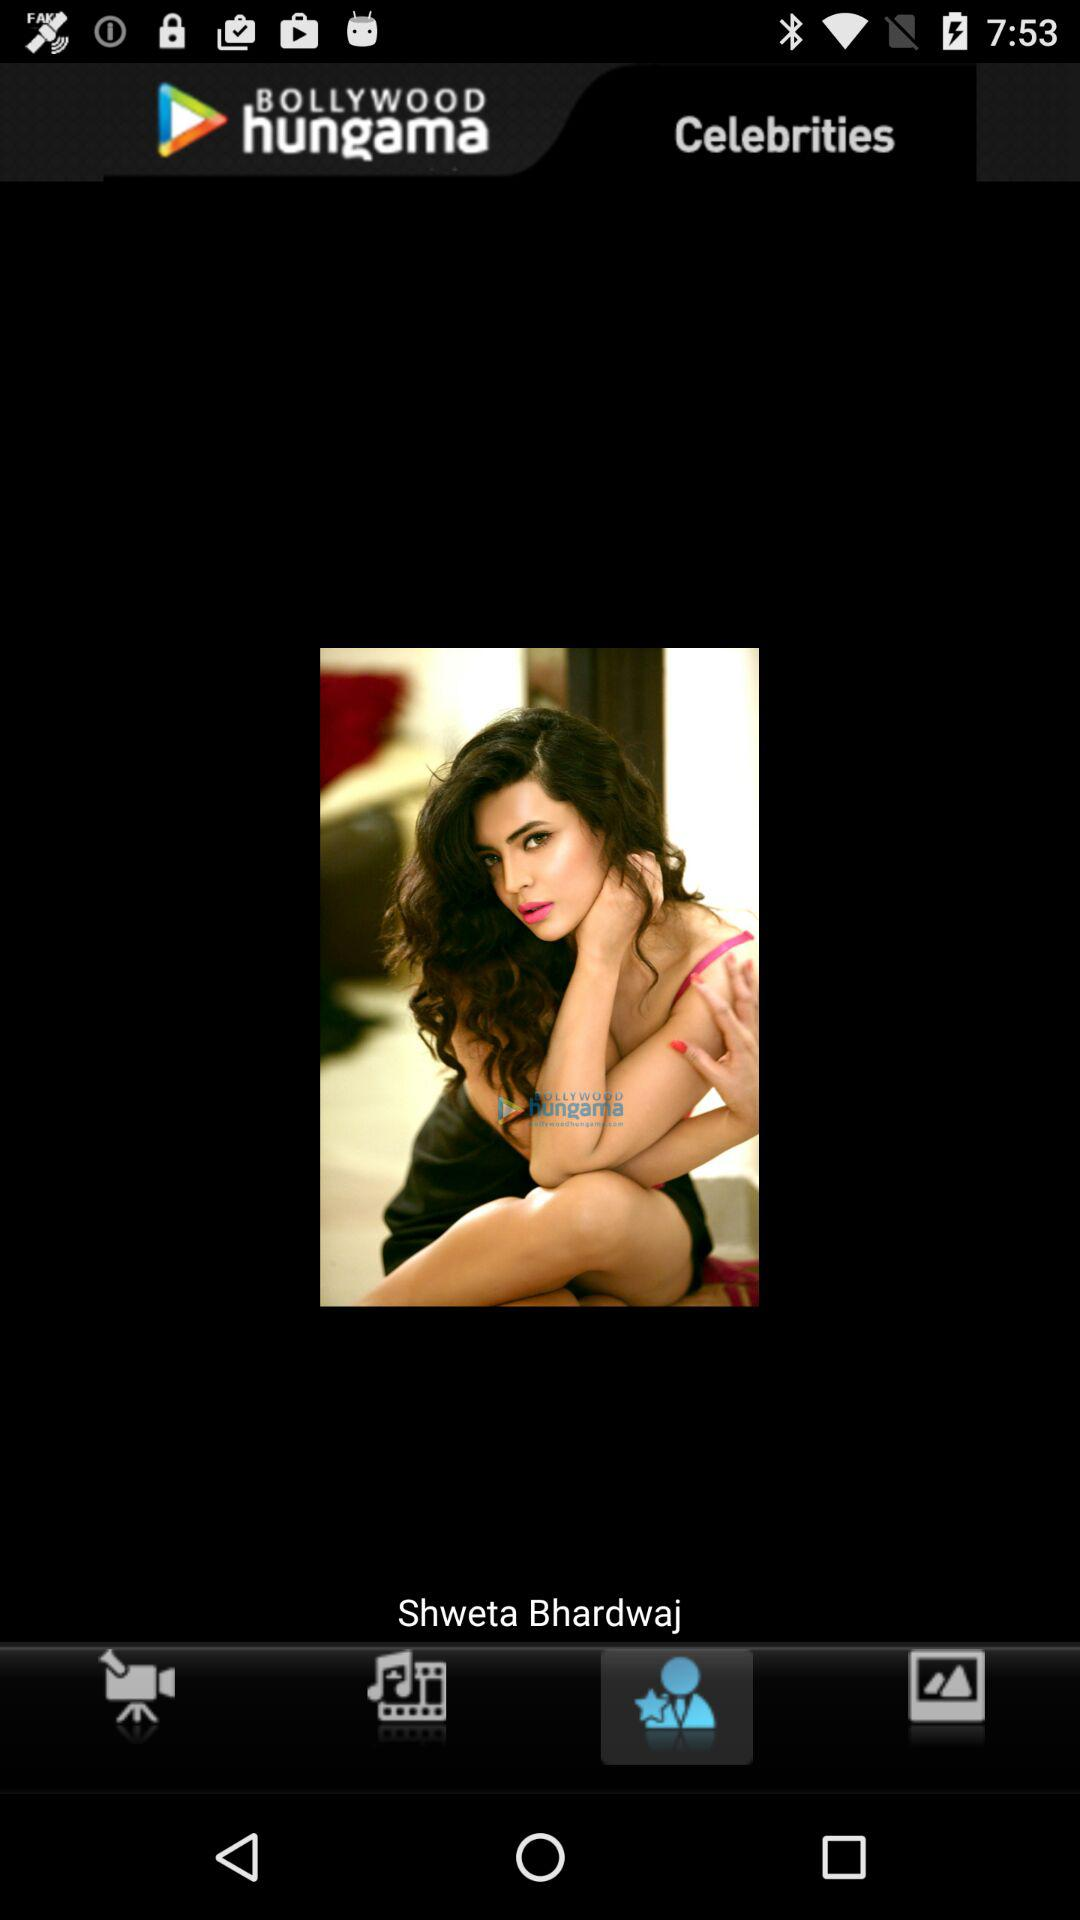What is the name of the celebrity? The name of the celebrity is Shweta Bhardwaj. 